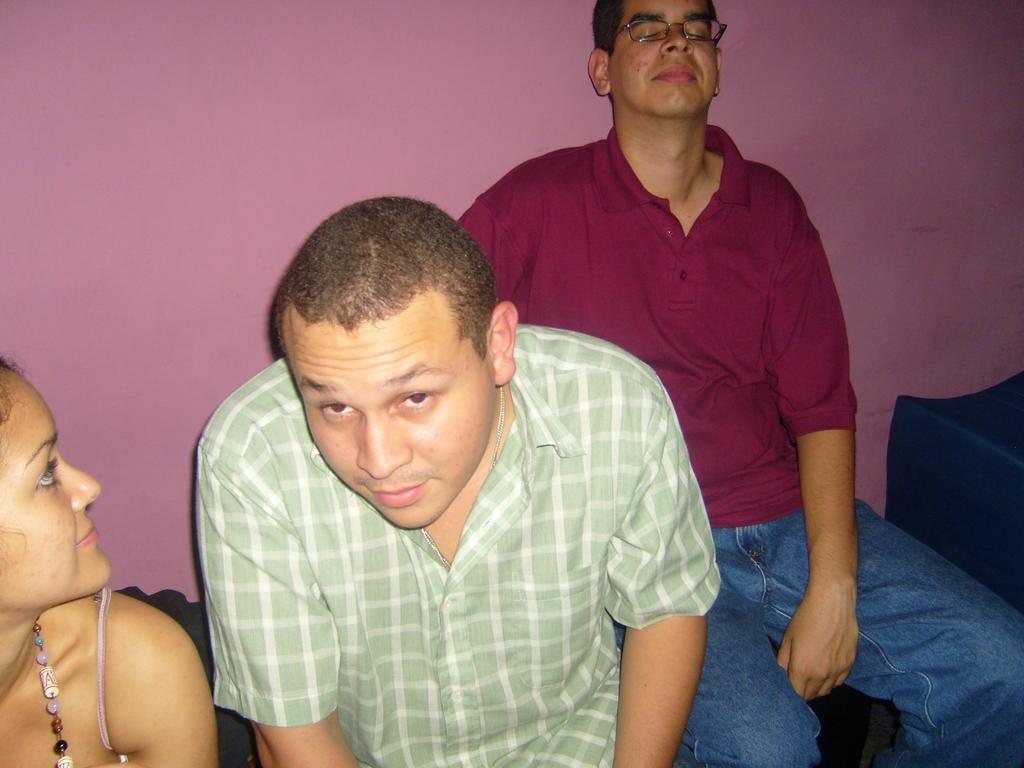In one or two sentences, can you explain what this image depicts? In this image there is one women is at left side of this image and there is one man standing in middle of this image and another person is at right side of this image and this person is wearing spectacles and there is a wall in the background. 